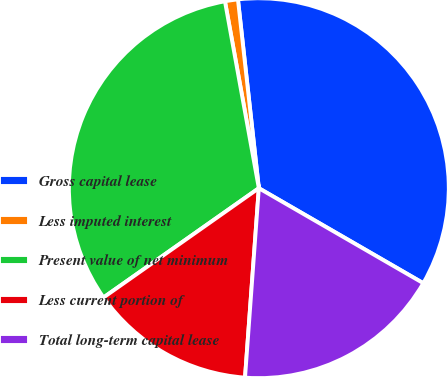Convert chart. <chart><loc_0><loc_0><loc_500><loc_500><pie_chart><fcel>Gross capital lease<fcel>Less imputed interest<fcel>Present value of net minimum<fcel>Less current portion of<fcel>Total long-term capital lease<nl><fcel>35.09%<fcel>1.1%<fcel>31.9%<fcel>14.08%<fcel>17.82%<nl></chart> 